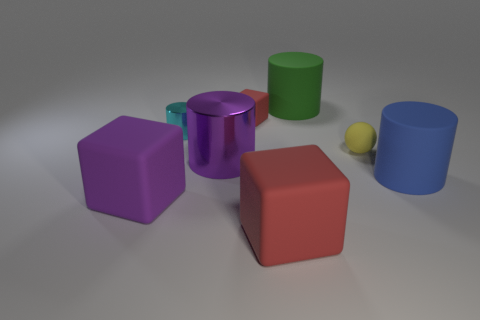Is there anything else that is the same material as the small cube?
Your answer should be very brief. Yes. There is a red block behind the tiny ball; what is its material?
Offer a terse response. Rubber. How many red things are either small rubber things or small blocks?
Provide a short and direct response. 1. Do the green cylinder and the large purple object that is behind the blue object have the same material?
Keep it short and to the point. No. Is the number of small balls behind the small cyan thing the same as the number of blue matte things left of the blue rubber cylinder?
Your answer should be very brief. Yes. There is a purple shiny object; is its size the same as the object right of the ball?
Your answer should be very brief. Yes. Are there more small red matte blocks behind the cyan thing than yellow metal cylinders?
Offer a terse response. Yes. How many red matte cubes have the same size as the sphere?
Give a very brief answer. 1. There is a red cube that is in front of the big metallic cylinder; does it have the same size as the cube that is behind the yellow object?
Provide a short and direct response. No. Is the number of tiny red rubber things to the right of the rubber ball greater than the number of tiny yellow matte things in front of the big red matte cube?
Keep it short and to the point. No. 